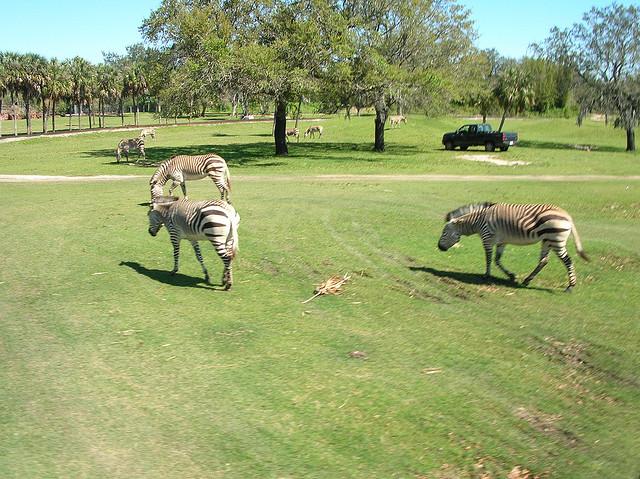Is there a human presence?
Answer briefly. Yes. How many vehicles are in this picture?
Answer briefly. 1. How many zebras are there in the foreground?
Answer briefly. 3. 